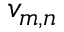Convert formula to latex. <formula><loc_0><loc_0><loc_500><loc_500>v _ { m , n }</formula> 